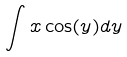Convert formula to latex. <formula><loc_0><loc_0><loc_500><loc_500>\int x \cos ( y ) d y</formula> 